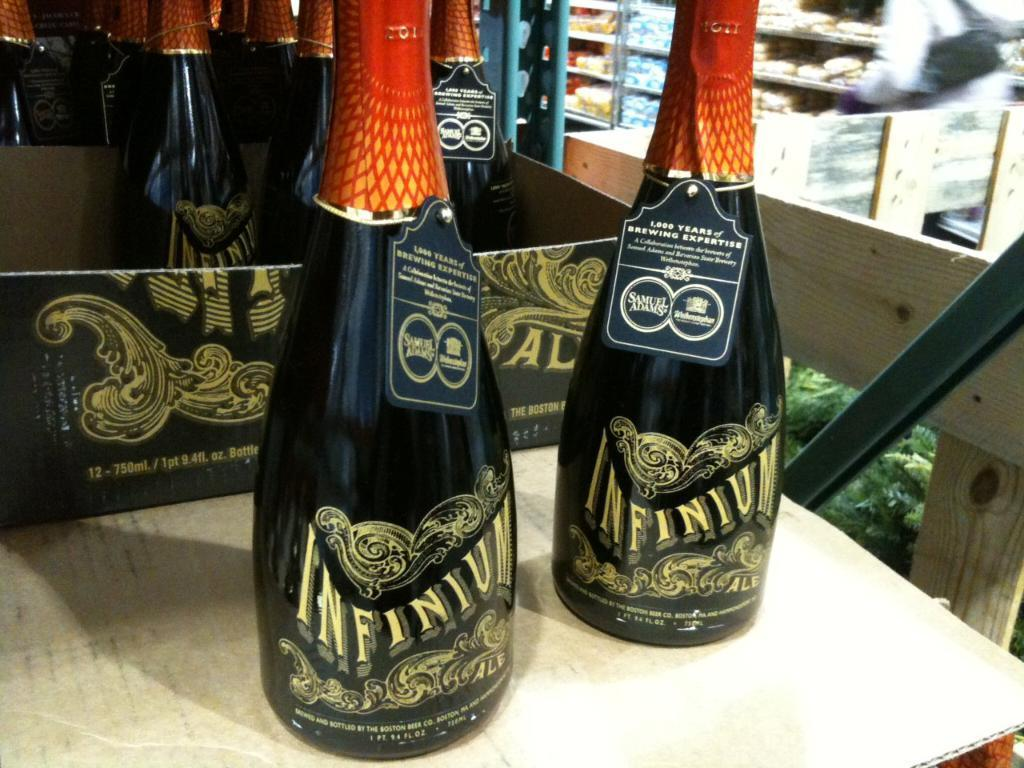<image>
Render a clear and concise summary of the photo. Two bottles of Infinium are displayed on a table 